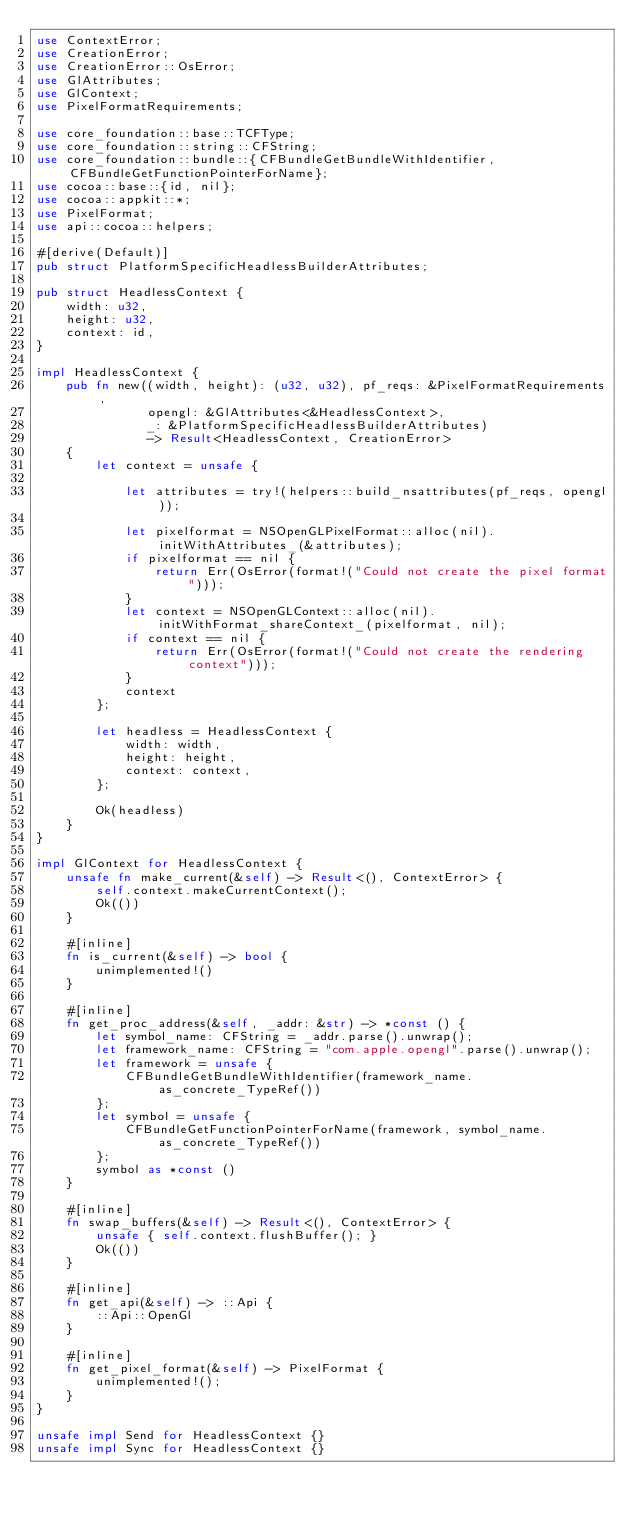Convert code to text. <code><loc_0><loc_0><loc_500><loc_500><_Rust_>use ContextError;
use CreationError;
use CreationError::OsError;
use GlAttributes;
use GlContext;
use PixelFormatRequirements;

use core_foundation::base::TCFType;
use core_foundation::string::CFString;
use core_foundation::bundle::{CFBundleGetBundleWithIdentifier, CFBundleGetFunctionPointerForName};
use cocoa::base::{id, nil};
use cocoa::appkit::*;
use PixelFormat;
use api::cocoa::helpers;

#[derive(Default)]
pub struct PlatformSpecificHeadlessBuilderAttributes;

pub struct HeadlessContext {
    width: u32,
    height: u32,
    context: id,
}

impl HeadlessContext {
    pub fn new((width, height): (u32, u32), pf_reqs: &PixelFormatRequirements,
               opengl: &GlAttributes<&HeadlessContext>,
               _: &PlatformSpecificHeadlessBuilderAttributes)
               -> Result<HeadlessContext, CreationError>
    {
        let context = unsafe {

            let attributes = try!(helpers::build_nsattributes(pf_reqs, opengl));

            let pixelformat = NSOpenGLPixelFormat::alloc(nil).initWithAttributes_(&attributes);
            if pixelformat == nil {
                return Err(OsError(format!("Could not create the pixel format")));
            }
            let context = NSOpenGLContext::alloc(nil).initWithFormat_shareContext_(pixelformat, nil);
            if context == nil {
                return Err(OsError(format!("Could not create the rendering context")));
            }
            context
        };

        let headless = HeadlessContext {
            width: width,
            height: height,
            context: context,
        };

        Ok(headless)
    }
}

impl GlContext for HeadlessContext {
    unsafe fn make_current(&self) -> Result<(), ContextError> {
        self.context.makeCurrentContext();
        Ok(())
    }

    #[inline]
    fn is_current(&self) -> bool {
        unimplemented!()
    }

    #[inline]
    fn get_proc_address(&self, _addr: &str) -> *const () {
        let symbol_name: CFString = _addr.parse().unwrap();
        let framework_name: CFString = "com.apple.opengl".parse().unwrap();
        let framework = unsafe {
            CFBundleGetBundleWithIdentifier(framework_name.as_concrete_TypeRef())
        };
        let symbol = unsafe {
            CFBundleGetFunctionPointerForName(framework, symbol_name.as_concrete_TypeRef())
        };
        symbol as *const ()
    }

    #[inline]
    fn swap_buffers(&self) -> Result<(), ContextError> {
        unsafe { self.context.flushBuffer(); }
        Ok(())
    }

    #[inline]
    fn get_api(&self) -> ::Api {
        ::Api::OpenGl
    }

    #[inline]
    fn get_pixel_format(&self) -> PixelFormat {
        unimplemented!();
    }
}

unsafe impl Send for HeadlessContext {}
unsafe impl Sync for HeadlessContext {}
</code> 